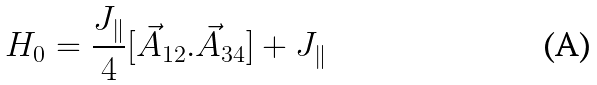Convert formula to latex. <formula><loc_0><loc_0><loc_500><loc_500>H _ { 0 } = \frac { J _ { \| } } { 4 } [ \vec { A } _ { 1 2 } . \vec { A } _ { 3 4 } ] + J _ { \| }</formula> 